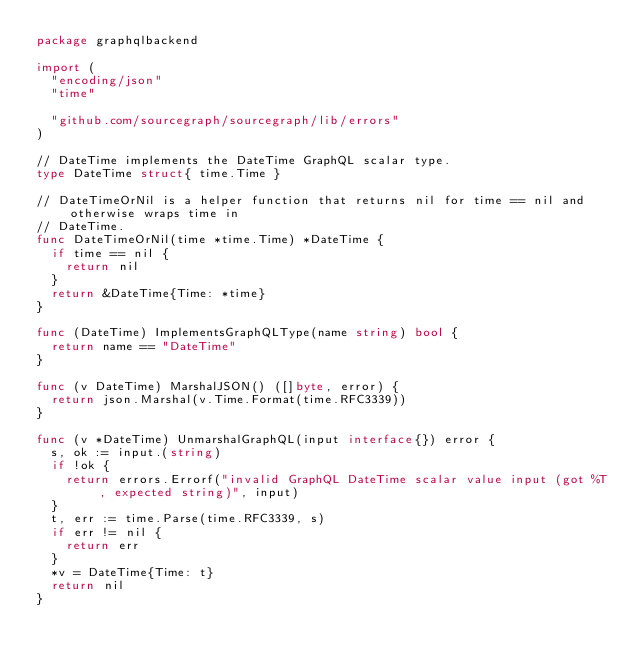<code> <loc_0><loc_0><loc_500><loc_500><_Go_>package graphqlbackend

import (
	"encoding/json"
	"time"

	"github.com/sourcegraph/sourcegraph/lib/errors"
)

// DateTime implements the DateTime GraphQL scalar type.
type DateTime struct{ time.Time }

// DateTimeOrNil is a helper function that returns nil for time == nil and otherwise wraps time in
// DateTime.
func DateTimeOrNil(time *time.Time) *DateTime {
	if time == nil {
		return nil
	}
	return &DateTime{Time: *time}
}

func (DateTime) ImplementsGraphQLType(name string) bool {
	return name == "DateTime"
}

func (v DateTime) MarshalJSON() ([]byte, error) {
	return json.Marshal(v.Time.Format(time.RFC3339))
}

func (v *DateTime) UnmarshalGraphQL(input interface{}) error {
	s, ok := input.(string)
	if !ok {
		return errors.Errorf("invalid GraphQL DateTime scalar value input (got %T, expected string)", input)
	}
	t, err := time.Parse(time.RFC3339, s)
	if err != nil {
		return err
	}
	*v = DateTime{Time: t}
	return nil
}
</code> 